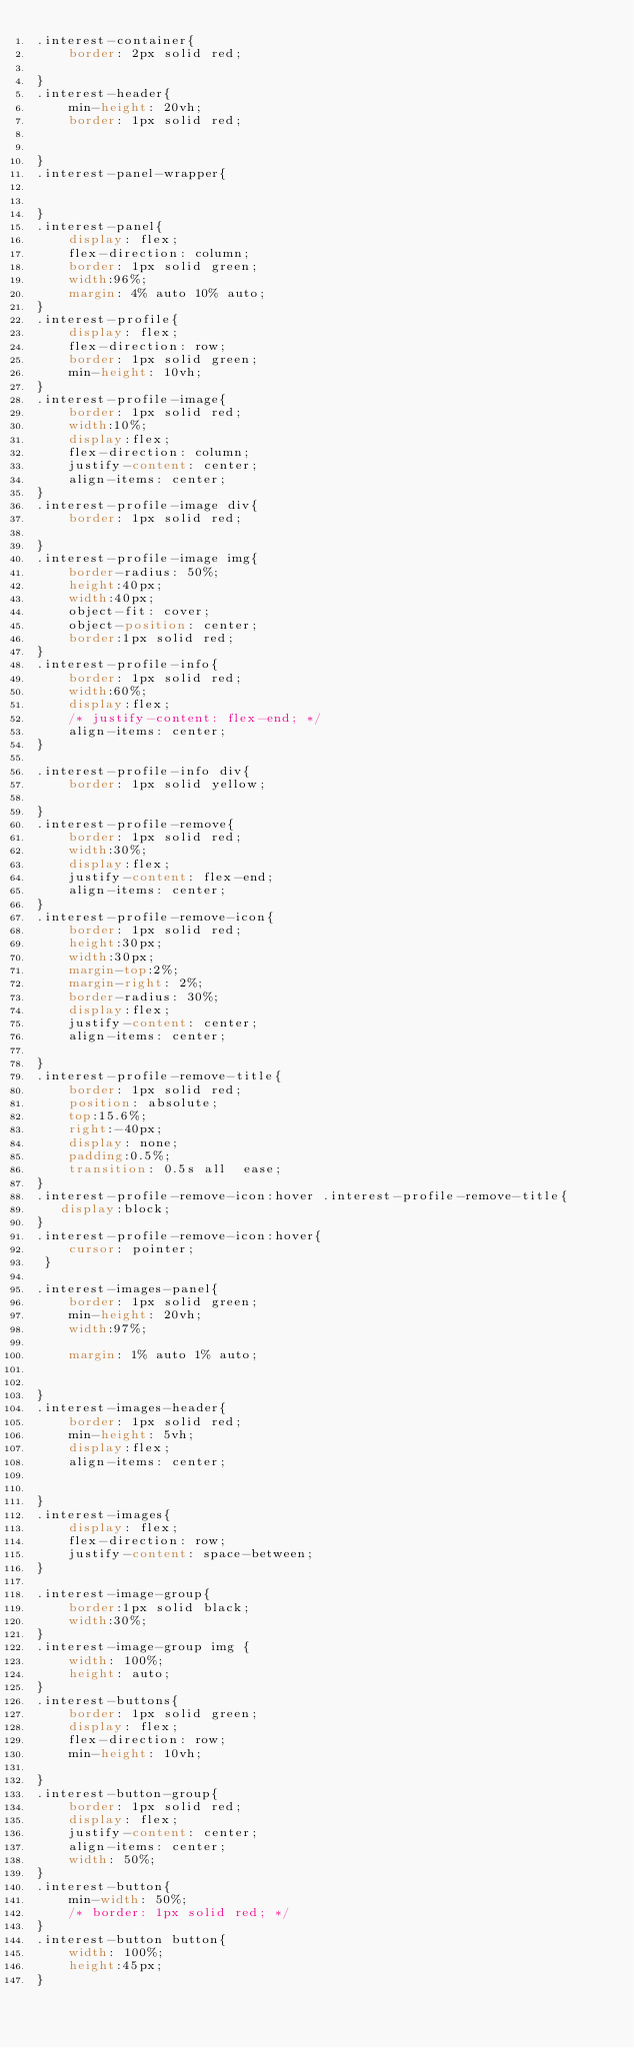Convert code to text. <code><loc_0><loc_0><loc_500><loc_500><_CSS_>.interest-container{
    border: 2px solid red;
    
}
.interest-header{
    min-height: 20vh;
    border: 1px solid red;


}
.interest-panel-wrapper{
   

}
.interest-panel{
    display: flex;
    flex-direction: column;
    border: 1px solid green;
    width:96%;
    margin: 4% auto 10% auto;
}
.interest-profile{
    display: flex;
    flex-direction: row;
    border: 1px solid green;
    min-height: 10vh;
}
.interest-profile-image{
    border: 1px solid red;
    width:10%;
    display:flex;
    flex-direction: column;
    justify-content: center;
    align-items: center;
}
.interest-profile-image div{
    border: 1px solid red;
   
}
.interest-profile-image img{ 
    border-radius: 50%; 
    height:40px;
    width:40px;
    object-fit: cover;
    object-position: center;
    border:1px solid red;
}
.interest-profile-info{
    border: 1px solid red;
    width:60%;
    display:flex;
    /* justify-content: flex-end; */
    align-items: center;
}

.interest-profile-info div{
    border: 1px solid yellow; 
    
}
.interest-profile-remove{
    border: 1px solid red;
    width:30%;
    display:flex;
    justify-content: flex-end;
    align-items: center;
}
.interest-profile-remove-icon{
    border: 1px solid red;
    height:30px;
    width:30px;
    margin-top:2%;
    margin-right: 2%;
    border-radius: 30%; 
    display:flex;
    justify-content: center;
    align-items: center;
    
}
.interest-profile-remove-title{
    border: 1px solid red;
    position: absolute;
    top:15.6%;
    right:-40px;
    display: none;
    padding:0.5%;
    transition: 0.5s all  ease;
}
.interest-profile-remove-icon:hover .interest-profile-remove-title{
   display:block;  
}
.interest-profile-remove-icon:hover{
    cursor: pointer;   
 }

.interest-images-panel{
    border: 1px solid green;
    min-height: 20vh;
    width:97%;
   
    margin: 1% auto 1% auto;
    

}
.interest-images-header{
    border: 1px solid red;
    min-height: 5vh;
    display:flex;
    align-items: center;


}
.interest-images{
    display: flex;
    flex-direction: row;
    justify-content: space-between;
}

.interest-image-group{
    border:1px solid black;
    width:30%;
}
.interest-image-group img {
    width: 100%;
    height: auto;   
}
.interest-buttons{
    border: 1px solid green;
    display: flex;
    flex-direction: row;
    min-height: 10vh;

}
.interest-button-group{
    border: 1px solid red;
    display: flex;
    justify-content: center;
    align-items: center;
    width: 50%;
}
.interest-button{
    min-width: 50%;
    /* border: 1px solid red; */
} 
.interest-button button{
    width: 100%;
    height:45px;
}</code> 